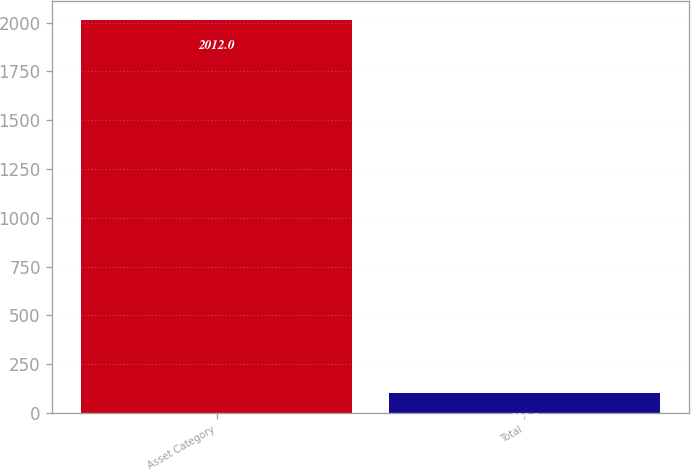Convert chart. <chart><loc_0><loc_0><loc_500><loc_500><bar_chart><fcel>Asset Category<fcel>Total<nl><fcel>2012<fcel>100<nl></chart> 